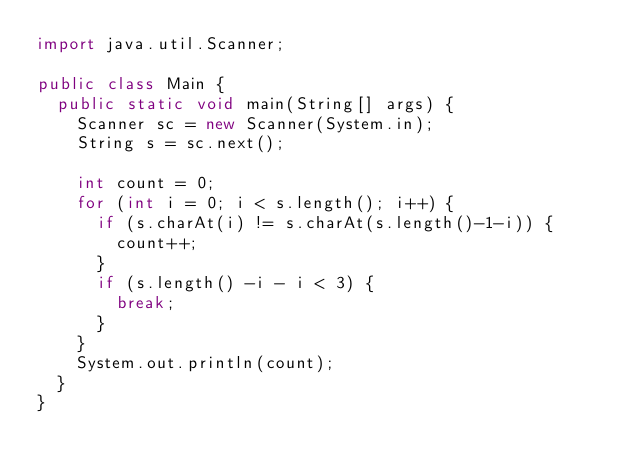<code> <loc_0><loc_0><loc_500><loc_500><_Java_>import java.util.Scanner;

public class Main {
  public static void main(String[] args) {
    Scanner sc = new Scanner(System.in);
    String s = sc.next();

    int count = 0;
    for (int i = 0; i < s.length(); i++) {
      if (s.charAt(i) != s.charAt(s.length()-1-i)) {
        count++;
      }
      if (s.length() -i - i < 3) {
        break;
      }
    }
    System.out.println(count);
  }
}
</code> 